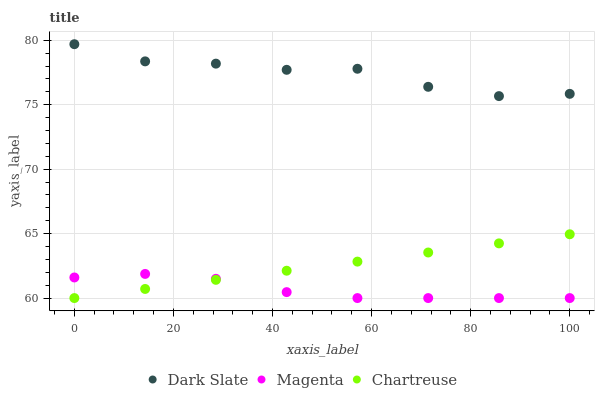Does Magenta have the minimum area under the curve?
Answer yes or no. Yes. Does Dark Slate have the maximum area under the curve?
Answer yes or no. Yes. Does Chartreuse have the minimum area under the curve?
Answer yes or no. No. Does Chartreuse have the maximum area under the curve?
Answer yes or no. No. Is Chartreuse the smoothest?
Answer yes or no. Yes. Is Dark Slate the roughest?
Answer yes or no. Yes. Is Magenta the smoothest?
Answer yes or no. No. Is Magenta the roughest?
Answer yes or no. No. Does Magenta have the lowest value?
Answer yes or no. Yes. Does Dark Slate have the highest value?
Answer yes or no. Yes. Does Chartreuse have the highest value?
Answer yes or no. No. Is Magenta less than Dark Slate?
Answer yes or no. Yes. Is Dark Slate greater than Magenta?
Answer yes or no. Yes. Does Chartreuse intersect Magenta?
Answer yes or no. Yes. Is Chartreuse less than Magenta?
Answer yes or no. No. Is Chartreuse greater than Magenta?
Answer yes or no. No. Does Magenta intersect Dark Slate?
Answer yes or no. No. 